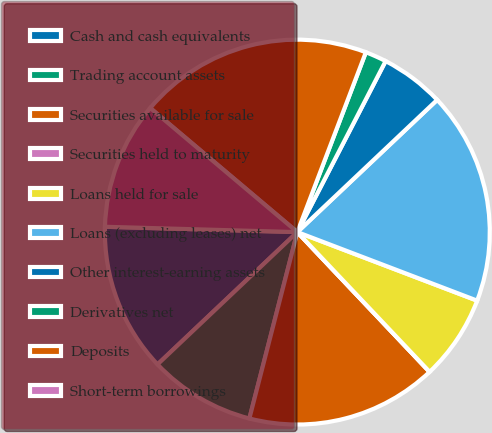<chart> <loc_0><loc_0><loc_500><loc_500><pie_chart><fcel>Cash and cash equivalents<fcel>Trading account assets<fcel>Securities available for sale<fcel>Securities held to maturity<fcel>Loans held for sale<fcel>Loans (excluding leases) net<fcel>Other interest-earning assets<fcel>Derivatives net<fcel>Deposits<fcel>Short-term borrowings<nl><fcel>12.5%<fcel>8.93%<fcel>16.07%<fcel>0.0%<fcel>7.14%<fcel>17.85%<fcel>5.36%<fcel>1.79%<fcel>19.64%<fcel>10.71%<nl></chart> 